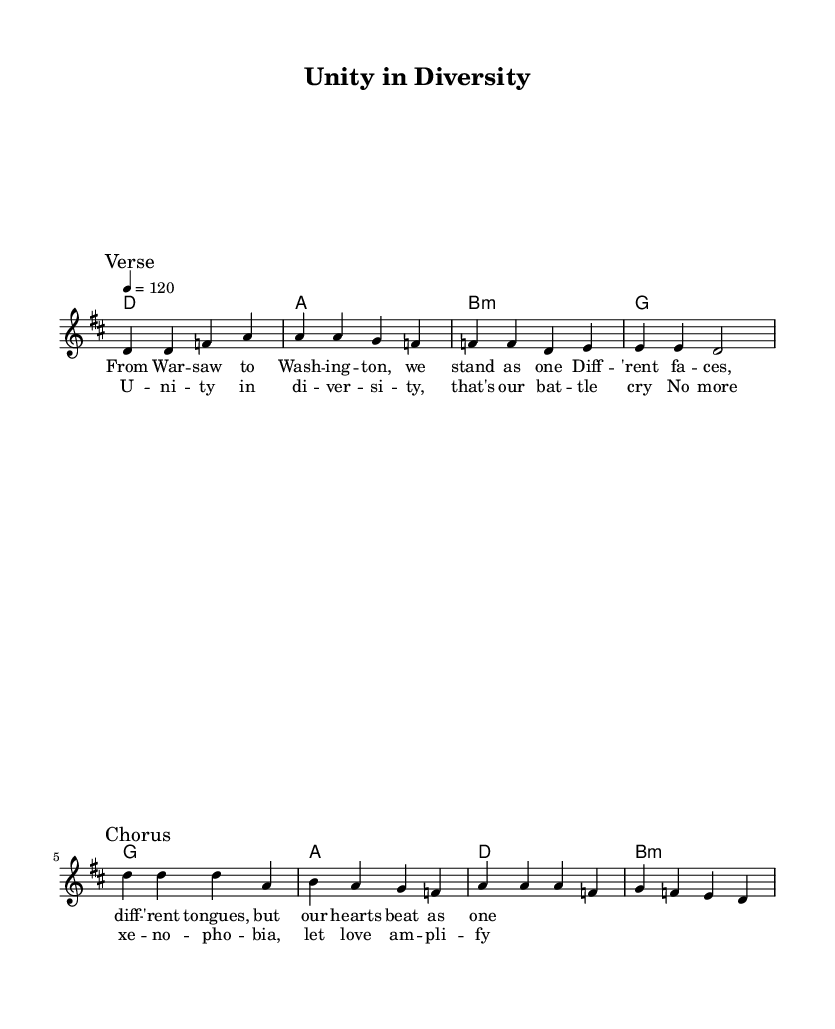What is the key signature of this music? The key signature shown at the beginning of the staff indicates two sharps, which are F# and C#. This corresponds to D major.
Answer: D major What is the time signature of the piece? The time signature is located next to the key signature and indicates that there are four beats in each measure. This is represented by "4/4."
Answer: 4/4 What is the tempo marking of the song? The tempo marking is indicated at the beginning of the piece and states "4 = 120," meaning there are 120 beats per minute.
Answer: 120 How many measures are in the verse section? To find the number of measures in the verse, we count the sections labeled and the bar lines within the verse notation, which reveal four measures.
Answer: 4 What is the primary theme presented in the lyrics? The lyrics describe unity among diverse people, emphasizing solidarity against xenophobia. The repeated phrases convey strength in diversity.
Answer: Unity in diversity What is the structure of the song? The structure follows a common format for rock songs, starting with a verse followed by a chorus. Additionally, the verses are repeated with the choruses reinforcing the message.
Answer: Verse-Chorus 